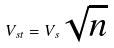Convert formula to latex. <formula><loc_0><loc_0><loc_500><loc_500>V _ { s t } = V _ { s } \sqrt { n }</formula> 